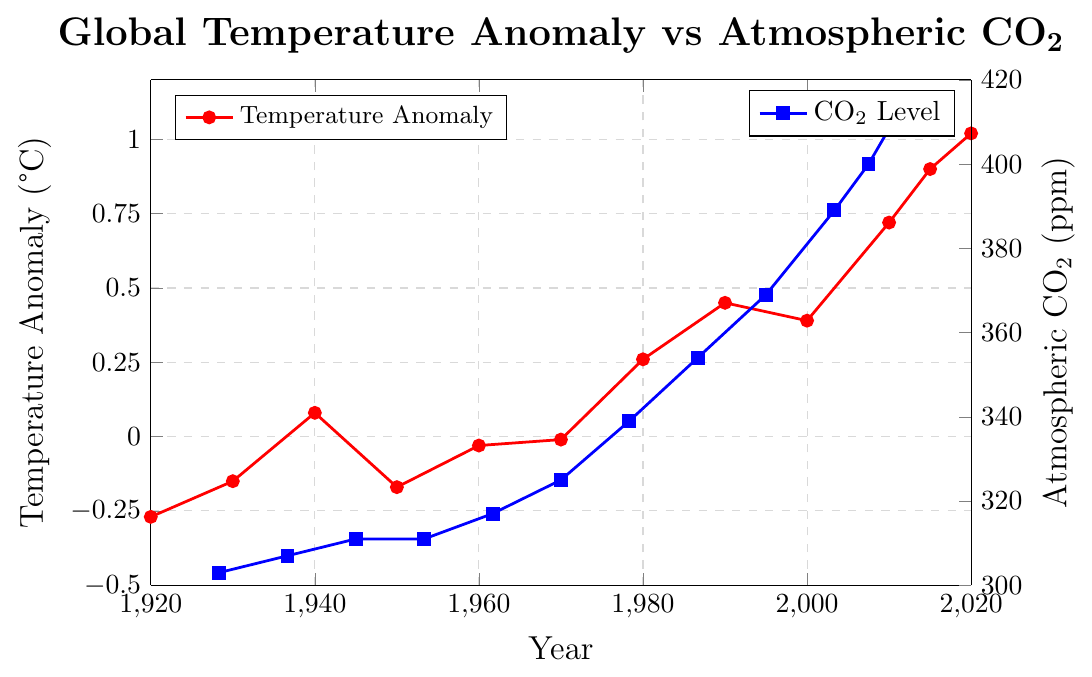What is the temperature anomaly in 1950? Locate the year 1950 on the bottom axis (x-axis) and then find the corresponding temperature anomaly (in red) on the left axis (y-axis).
Answer: -0.17°C What is the atmospheric CO2 level in 1990? Find the year 1990 on the bottom axis (x-axis) and trace vertically to the right-side y-axis to find the blue line value representing CO2 levels.
Answer: 354 ppm Between 1920 and 2020, in which decade did the global temperature anomaly increase the most? Observe the red line plot and compare the changes in temperature anomalies across each decade from 1920 to 2020. Calculate the differences and identify the decade with the largest increase.
Answer: 2010-2020 Compare the CO2 levels in 1940 and 1950. Which year had a higher level, and by how much? Look at the blue line plot for the CO2 levels in 1940 and 1950. Circle the respective coordinates and subtract 311 ppm (1950) from 311 ppm (1940). 311 ppm - 311 ppm = 0, so they are equal.
Answer: Equal, by 0 ppm What is the average global temperature anomaly from 2010 to 2020? Find the temperature anomaly values for 2010 and 2020 (0.72°C and 1.02°C, respectively). Calculate the average: (0.72 + 1.02)/2.
Answer: 0.87°C In what year did the atmospheric CO2 level first reach 400 ppm? Locate the point on the blue line plot where the CO2 level crosses 400 ppm. Identify the corresponding year on the x-axis.
Answer: 2015 By how much did the global temperature anomaly change from 1980 to 1990? Subtract the temperature anomaly in 1980 (0.26°C) from the value in 1990 (0.45°C). 0.45 - 0.26 = 0.19
Answer: 0.19°C How does the trend of global temperature anomalies compare to the trend of atmospheric CO2 levels over the century? Analyze both the red and blue lines from 1920 to 2020. Note the overall direction and rate of change for both temperature anomalies and CO2 levels.
Answer: Both trend upwards What is the range of atmospheric CO2 levels shown in the plot? Identify the minimum and maximum CO2 levels from the blue line plot: 303 ppm (1920) and 414 ppm (2020). Subtract the minimum from the maximum. 414 - 303 = 111
Answer: 111 ppm During which period did the global temperature anomaly remain relatively constant at first but then start to increase significantly? Observe the red line plot for any stretches of relatively constant values followed by a noticeable increase. The temperature anomaly stays around 0 to -0.1°C until about 1970, then increases significantly from 1980 onward.
Answer: Before 1970 